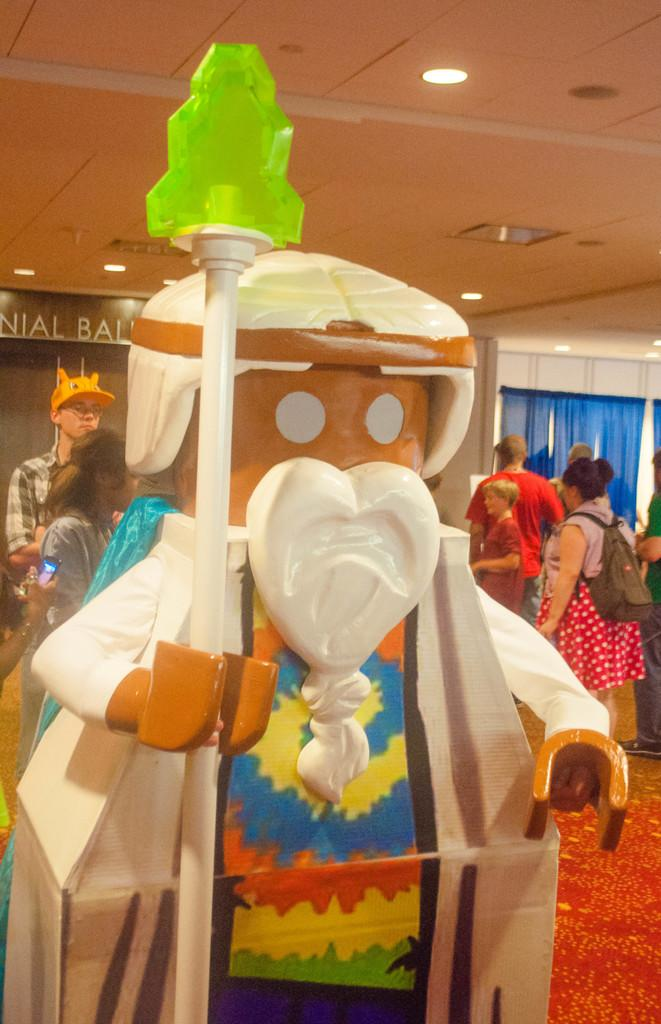What is located in the foreground of the image? There is a mannequin and a group of people on the floor in the foreground of the image. What can be seen in the background of the image? There is a wall, a rooftop, curtains, and lights in the background of the image. What might be the setting of the image? The image may have been taken in a hall. What type of fuel is being used by the nation depicted in the image? There is no nation depicted in the image, and therefore no information about the fuel being used. How does the mannequin's stomach appear in the image? The mannequin does not have a stomach, as it is an inanimate object. 